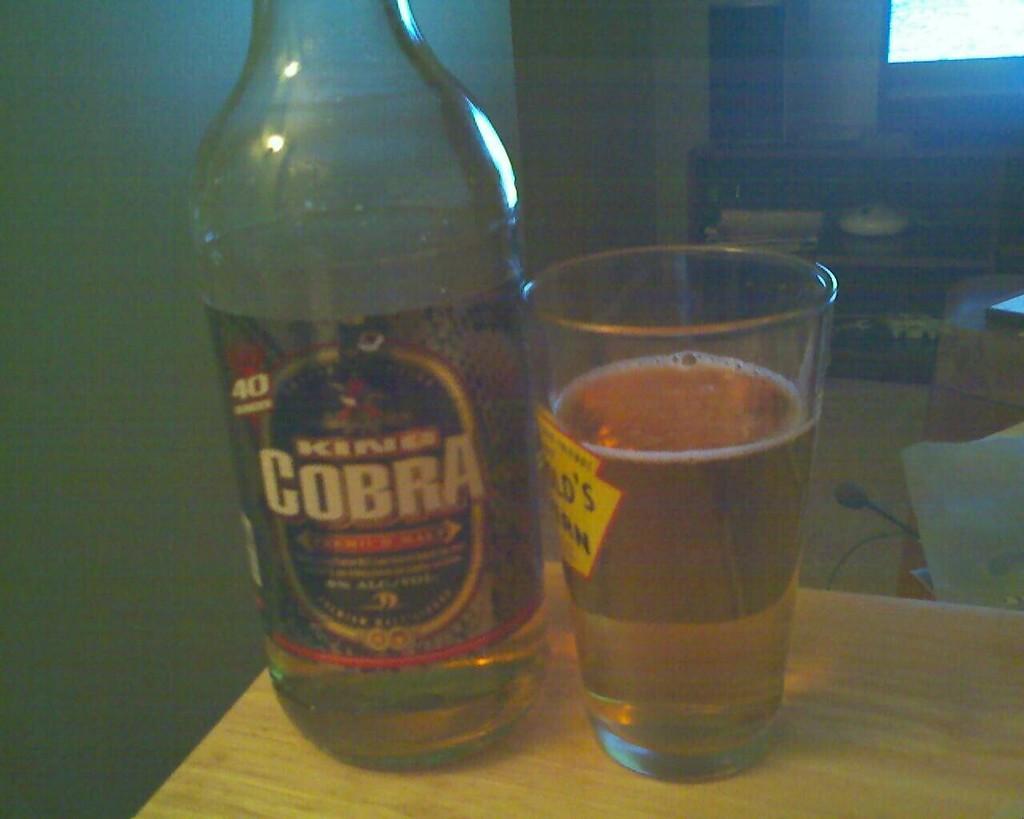Describe this image in one or two sentences. This is a beer bottle and this is a tumbler with beer in it are placed on the table. At background I can see a rack and some objects are placed inside it. 